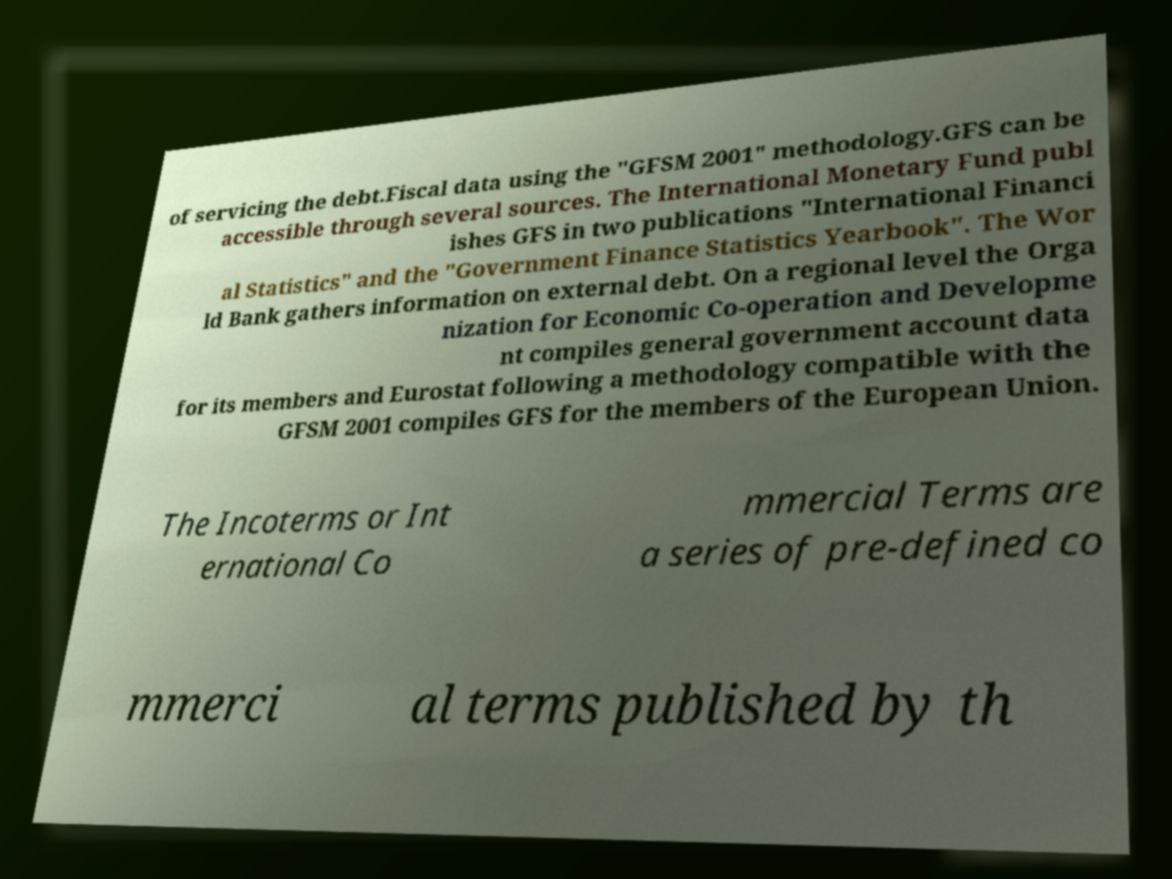I need the written content from this picture converted into text. Can you do that? of servicing the debt.Fiscal data using the "GFSM 2001" methodology.GFS can be accessible through several sources. The International Monetary Fund publ ishes GFS in two publications "International Financi al Statistics" and the "Government Finance Statistics Yearbook". The Wor ld Bank gathers information on external debt. On a regional level the Orga nization for Economic Co-operation and Developme nt compiles general government account data for its members and Eurostat following a methodology compatible with the GFSM 2001 compiles GFS for the members of the European Union. The Incoterms or Int ernational Co mmercial Terms are a series of pre-defined co mmerci al terms published by th 